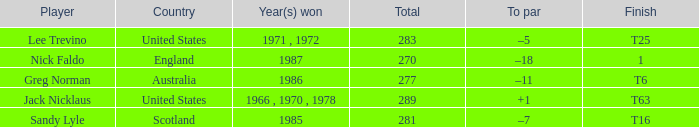How many totals have t6 as the finish? 277.0. 